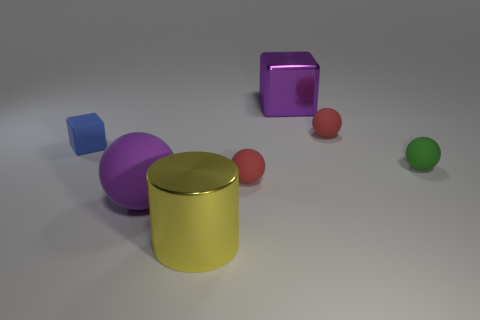Subtract all large spheres. How many spheres are left? 3 Add 2 purple metallic cubes. How many objects exist? 9 Subtract all blue cubes. How many cubes are left? 1 Subtract all purple cubes. How many red spheres are left? 2 Subtract 0 gray spheres. How many objects are left? 7 Subtract all blocks. How many objects are left? 5 Subtract 3 balls. How many balls are left? 1 Subtract all red spheres. Subtract all yellow blocks. How many spheres are left? 2 Subtract all tiny cylinders. Subtract all shiny objects. How many objects are left? 5 Add 5 tiny red rubber balls. How many tiny red rubber balls are left? 7 